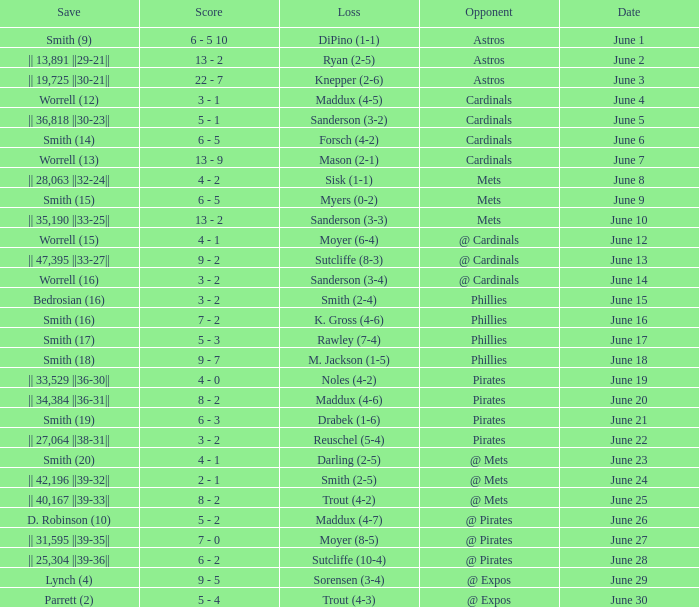The game with a loss of smith (2-4) ended with what score? 3 - 2. Could you help me parse every detail presented in this table? {'header': ['Save', 'Score', 'Loss', 'Opponent', 'Date'], 'rows': [['Smith (9)', '6 - 5 10', 'DiPino (1-1)', 'Astros', 'June 1'], ['|| 13,891 ||29-21||', '13 - 2', 'Ryan (2-5)', 'Astros', 'June 2'], ['|| 19,725 ||30-21||', '22 - 7', 'Knepper (2-6)', 'Astros', 'June 3'], ['Worrell (12)', '3 - 1', 'Maddux (4-5)', 'Cardinals', 'June 4'], ['|| 36,818 ||30-23||', '5 - 1', 'Sanderson (3-2)', 'Cardinals', 'June 5'], ['Smith (14)', '6 - 5', 'Forsch (4-2)', 'Cardinals', 'June 6'], ['Worrell (13)', '13 - 9', 'Mason (2-1)', 'Cardinals', 'June 7'], ['|| 28,063 ||32-24||', '4 - 2', 'Sisk (1-1)', 'Mets', 'June 8'], ['Smith (15)', '6 - 5', 'Myers (0-2)', 'Mets', 'June 9'], ['|| 35,190 ||33-25||', '13 - 2', 'Sanderson (3-3)', 'Mets', 'June 10'], ['Worrell (15)', '4 - 1', 'Moyer (6-4)', '@ Cardinals', 'June 12'], ['|| 47,395 ||33-27||', '9 - 2', 'Sutcliffe (8-3)', '@ Cardinals', 'June 13'], ['Worrell (16)', '3 - 2', 'Sanderson (3-4)', '@ Cardinals', 'June 14'], ['Bedrosian (16)', '3 - 2', 'Smith (2-4)', 'Phillies', 'June 15'], ['Smith (16)', '7 - 2', 'K. Gross (4-6)', 'Phillies', 'June 16'], ['Smith (17)', '5 - 3', 'Rawley (7-4)', 'Phillies', 'June 17'], ['Smith (18)', '9 - 7', 'M. Jackson (1-5)', 'Phillies', 'June 18'], ['|| 33,529 ||36-30||', '4 - 0', 'Noles (4-2)', 'Pirates', 'June 19'], ['|| 34,384 ||36-31||', '8 - 2', 'Maddux (4-6)', 'Pirates', 'June 20'], ['Smith (19)', '6 - 3', 'Drabek (1-6)', 'Pirates', 'June 21'], ['|| 27,064 ||38-31||', '3 - 2', 'Reuschel (5-4)', 'Pirates', 'June 22'], ['Smith (20)', '4 - 1', 'Darling (2-5)', '@ Mets', 'June 23'], ['|| 42,196 ||39-32||', '2 - 1', 'Smith (2-5)', '@ Mets', 'June 24'], ['|| 40,167 ||39-33||', '8 - 2', 'Trout (4-2)', '@ Mets', 'June 25'], ['D. Robinson (10)', '5 - 2', 'Maddux (4-7)', '@ Pirates', 'June 26'], ['|| 31,595 ||39-35||', '7 - 0', 'Moyer (8-5)', '@ Pirates', 'June 27'], ['|| 25,304 ||39-36||', '6 - 2', 'Sutcliffe (10-4)', '@ Pirates', 'June 28'], ['Lynch (4)', '9 - 5', 'Sorensen (3-4)', '@ Expos', 'June 29'], ['Parrett (2)', '5 - 4', 'Trout (4-3)', '@ Expos', 'June 30']]} 